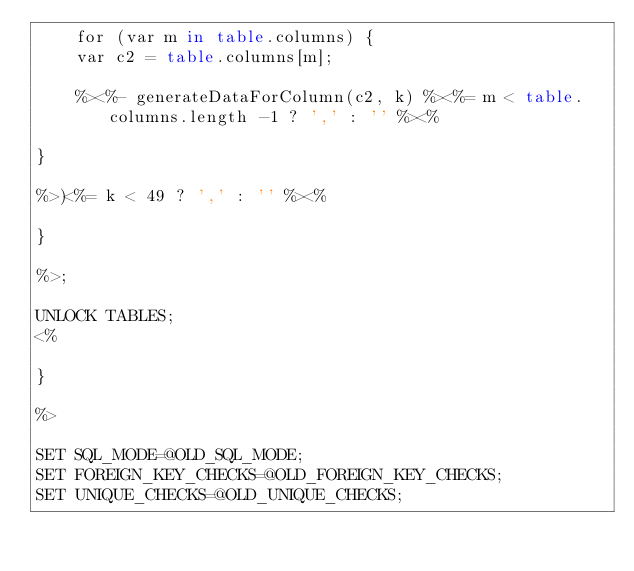<code> <loc_0><loc_0><loc_500><loc_500><_SQL_>	for (var m in table.columns) { 
	var c2 = table.columns[m]; 

	%><%- generateDataForColumn(c2, k) %><%= m < table.columns.length -1 ? ',' : '' %><% 

} 

%>)<%= k < 49 ? ',' : '' %><% 

} 

%>;

UNLOCK TABLES;
<% 

} 

%>

SET SQL_MODE=@OLD_SQL_MODE;
SET FOREIGN_KEY_CHECKS=@OLD_FOREIGN_KEY_CHECKS;
SET UNIQUE_CHECKS=@OLD_UNIQUE_CHECKS;
</code> 